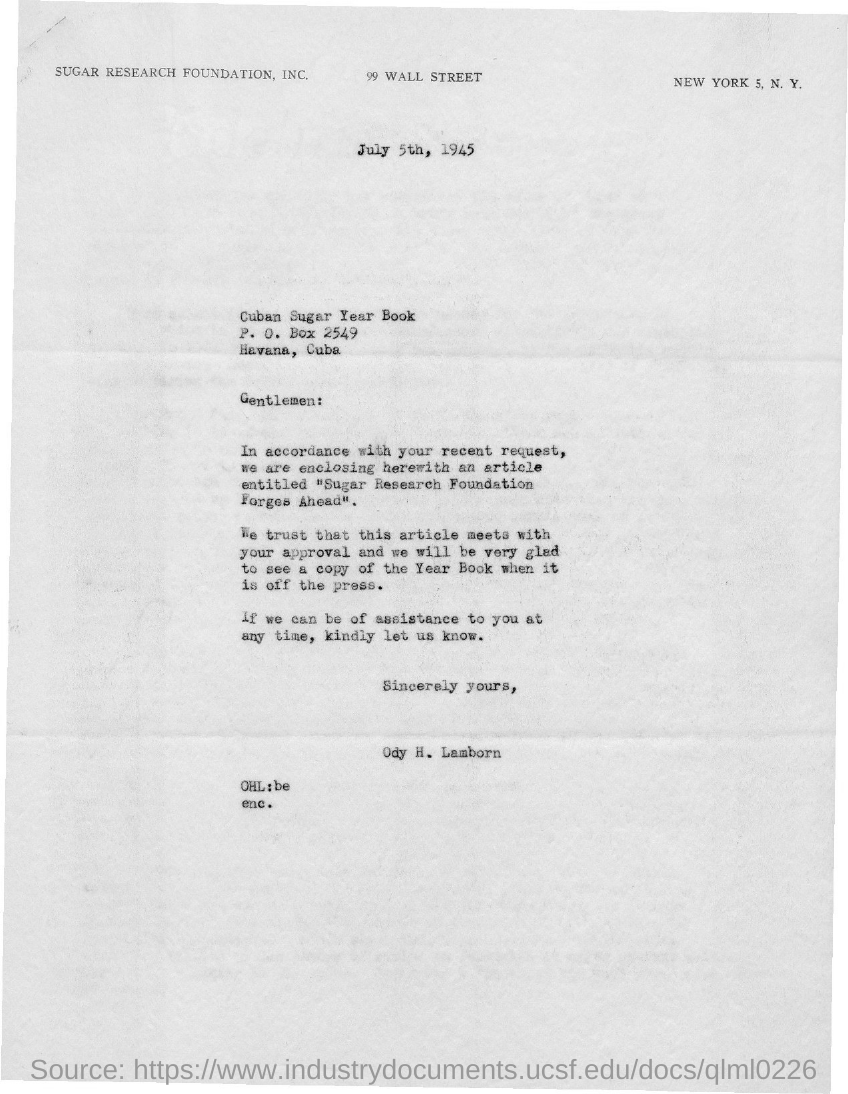Indicate a few pertinent items in this graphic. ODY H. LAMBORN is the sender of this letter. The letter is dated July 5th, 1945. The P.O.Box number given in the letter is 2549. 